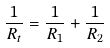<formula> <loc_0><loc_0><loc_500><loc_500>\frac { 1 } { R _ { t } } = \frac { 1 } { R _ { 1 } } + \frac { 1 } { R _ { 2 } }</formula> 